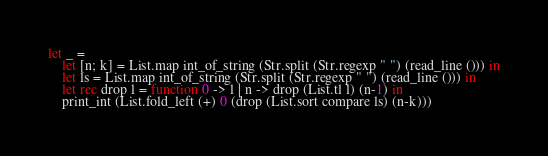Convert code to text. <code><loc_0><loc_0><loc_500><loc_500><_OCaml_>let _ =
    let [n; k] = List.map int_of_string (Str.split (Str.regexp " ") (read_line ())) in
    let ls = List.map int_of_string (Str.split (Str.regexp " ") (read_line ())) in
    let rec drop l = function 0 -> l | n -> drop (List.tl l) (n-1) in
    print_int (List.fold_left (+) 0 (drop (List.sort compare ls) (n-k)))</code> 